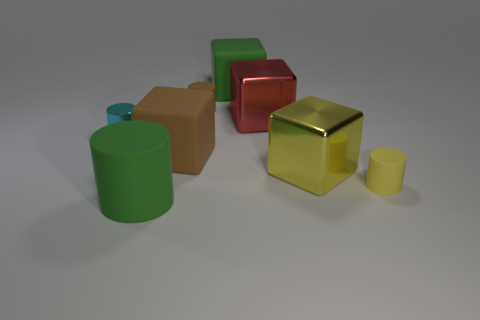Subtract 1 cylinders. How many cylinders are left? 3 Subtract all red blocks. Subtract all purple spheres. How many blocks are left? 3 Add 1 cyan metal blocks. How many objects exist? 9 Subtract all big red blocks. Subtract all tiny spheres. How many objects are left? 7 Add 5 big matte blocks. How many big matte blocks are left? 7 Add 3 large red metal things. How many large red metal things exist? 4 Subtract 0 red cylinders. How many objects are left? 8 